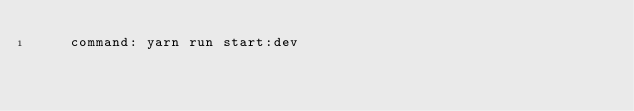<code> <loc_0><loc_0><loc_500><loc_500><_YAML_>    command: yarn run start:dev
</code> 